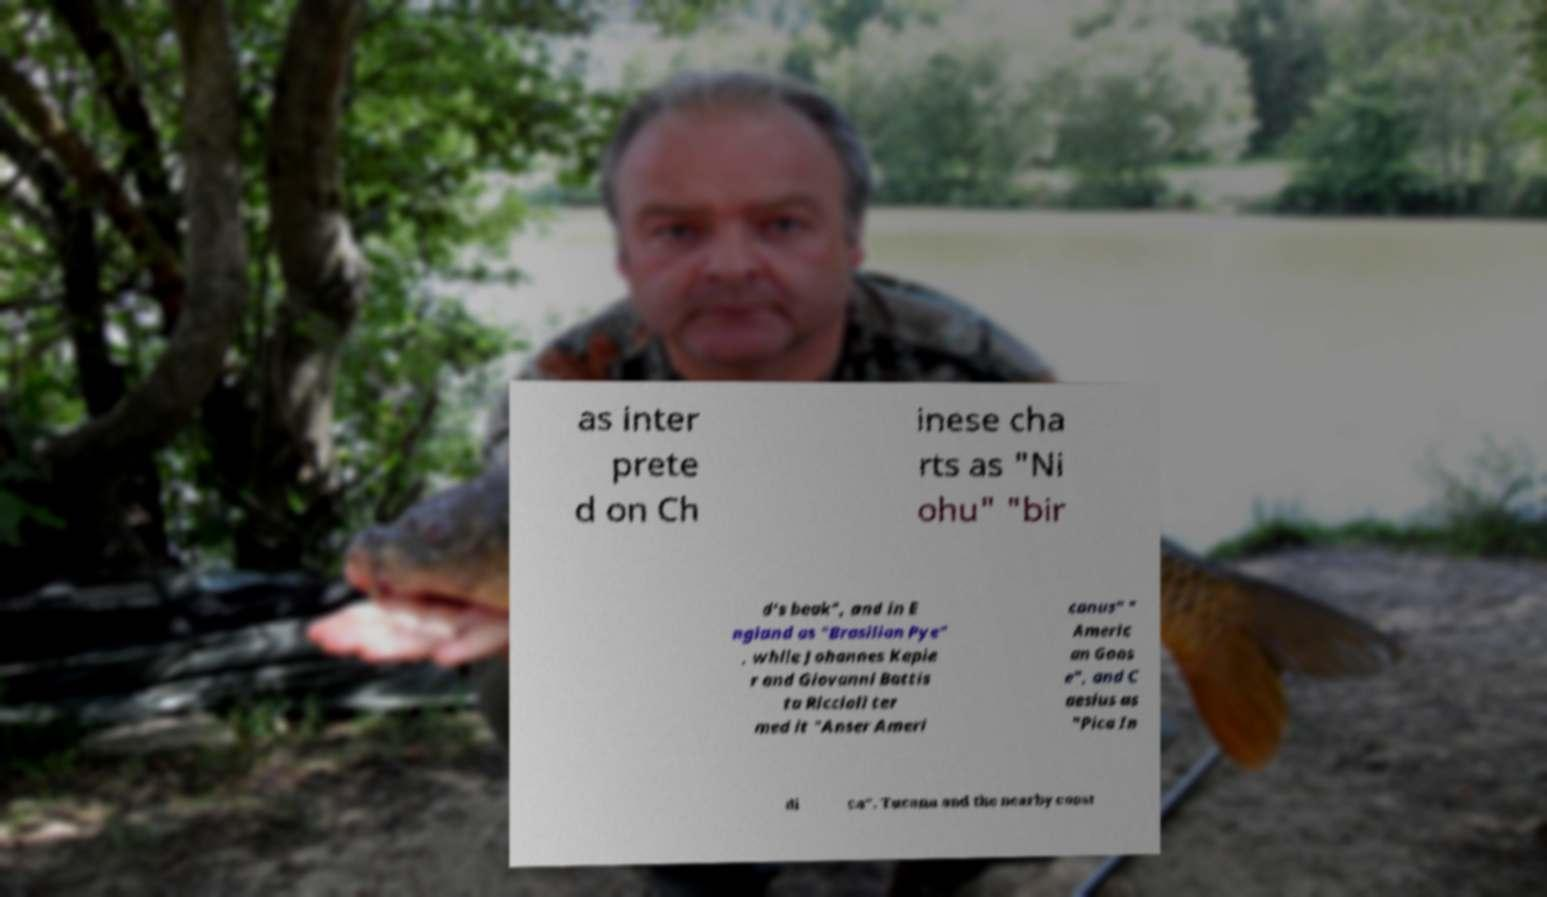Please identify and transcribe the text found in this image. as inter prete d on Ch inese cha rts as "Ni ohu" "bir d's beak", and in E ngland as "Brasilian Pye" , while Johannes Keple r and Giovanni Battis ta Riccioli ter med it "Anser Ameri canus" " Americ an Goos e", and C aesius as "Pica In di ca". Tucana and the nearby const 